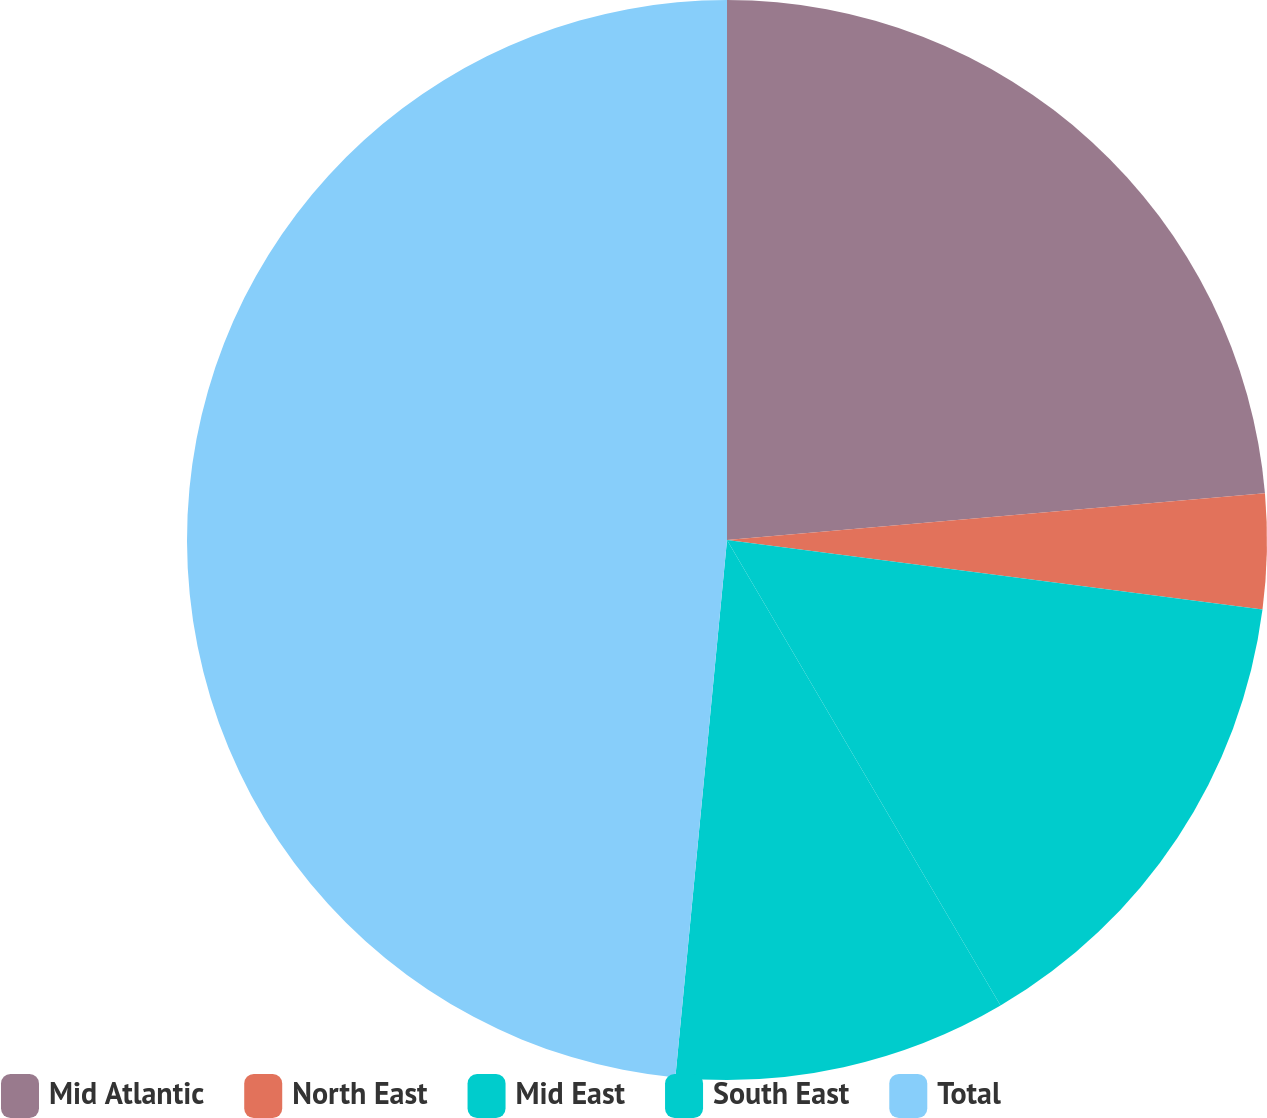Convert chart to OTSL. <chart><loc_0><loc_0><loc_500><loc_500><pie_chart><fcel>Mid Atlantic<fcel>North East<fcel>Mid East<fcel>South East<fcel>Total<nl><fcel>23.62%<fcel>3.44%<fcel>14.49%<fcel>9.98%<fcel>48.48%<nl></chart> 